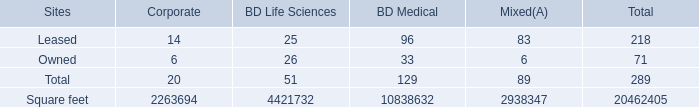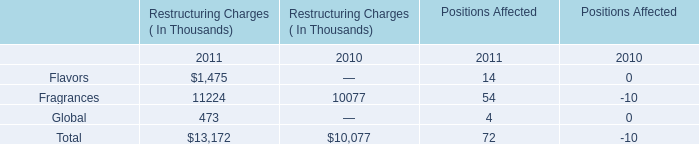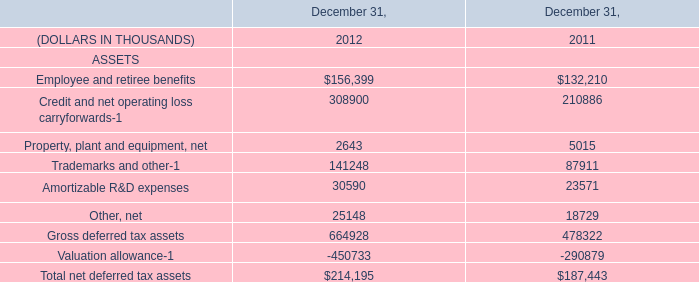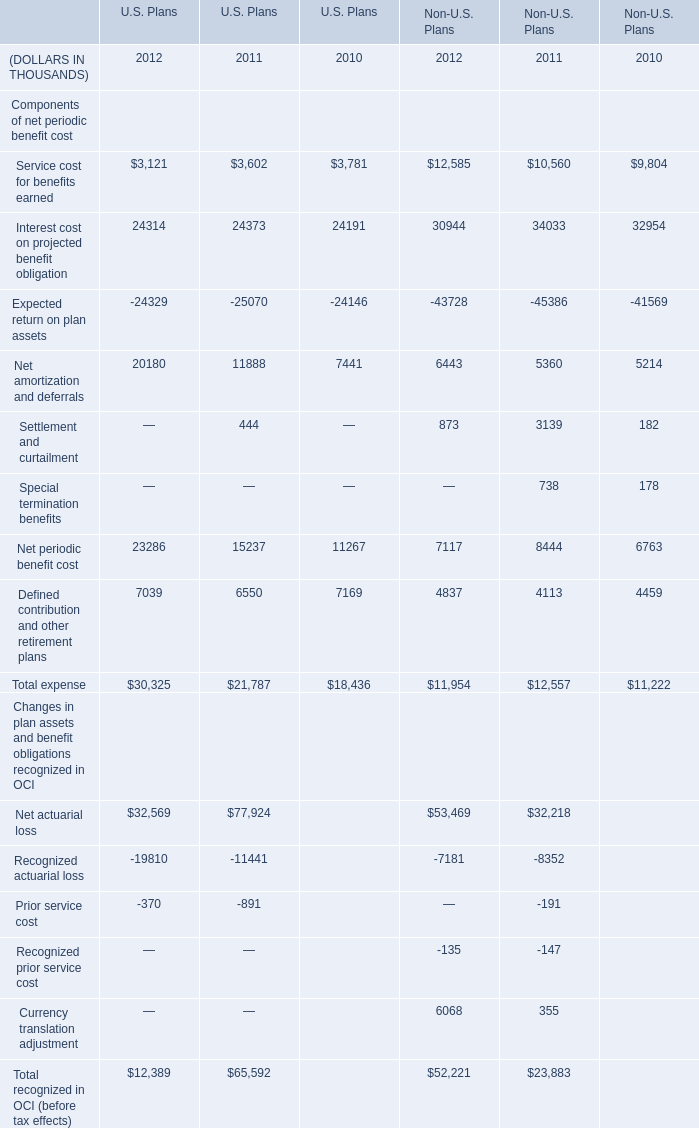If Net periodic benefit cost in terms of U.S. Plans develops with the same increasing rate in 2011, what will it reach in 2012? (in thousand) 
Computations: (15237 * (1 + ((15237 - 11267) / 11267)))
Answer: 20605.85506. 